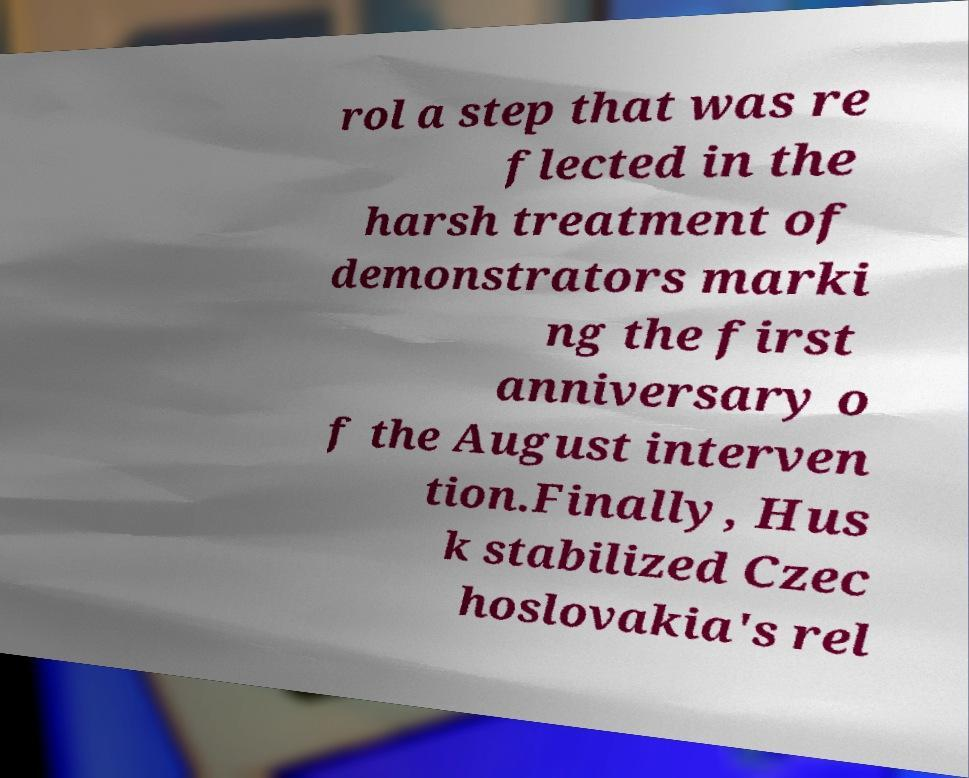For documentation purposes, I need the text within this image transcribed. Could you provide that? rol a step that was re flected in the harsh treatment of demonstrators marki ng the first anniversary o f the August interven tion.Finally, Hus k stabilized Czec hoslovakia's rel 